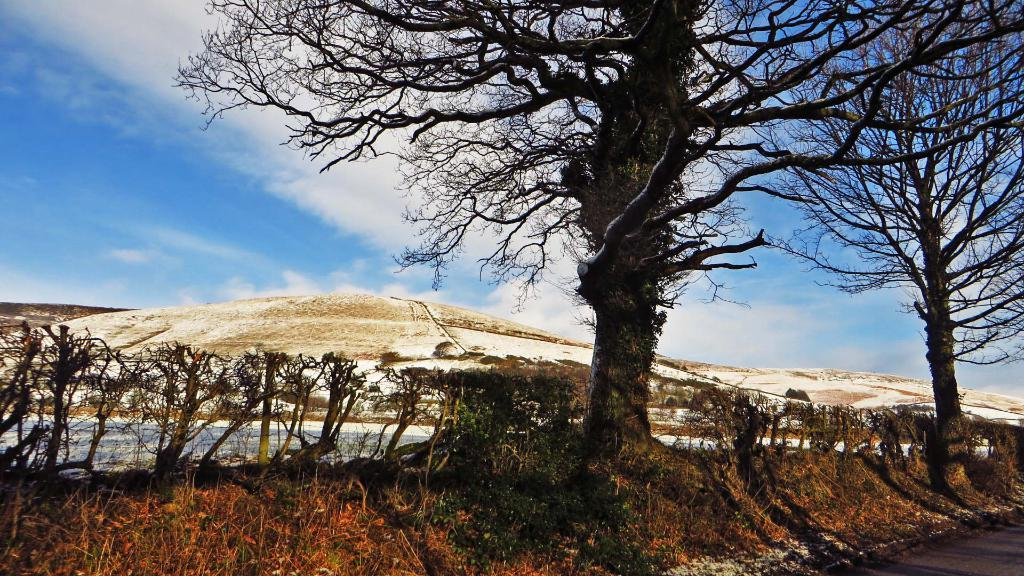What is the condition of the sky in the image? The sky is cloudy in the image. What type of vegetation can be seen in the image? There are trees and plants in the image. What can be seen in the distance in the image? There are mountains visible in the background of the image. What type of jar can be seen holding liquid in the image? There is no jar or liquid present in the image. What is the name of the downtown area visible in the image? There is no downtown area visible in the image; it features trees, plants, and mountains. 